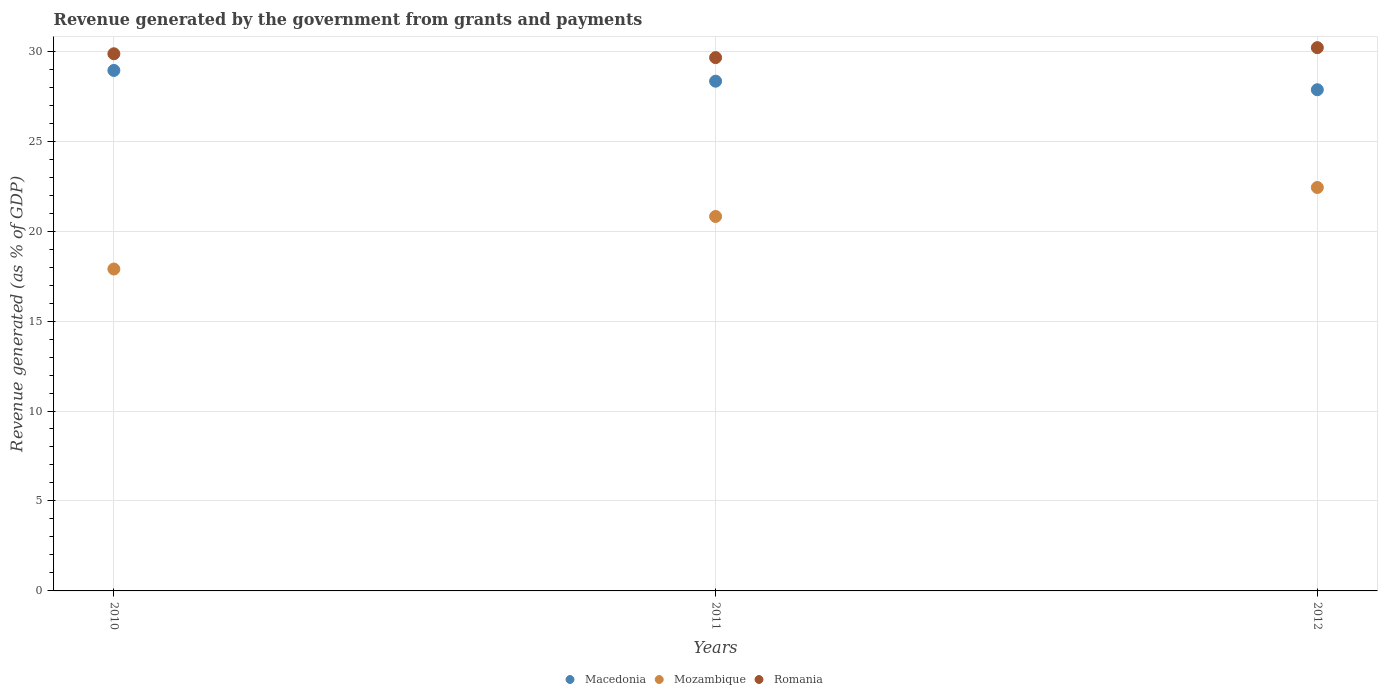What is the revenue generated by the government in Mozambique in 2011?
Provide a short and direct response. 20.81. Across all years, what is the maximum revenue generated by the government in Mozambique?
Offer a very short reply. 22.42. Across all years, what is the minimum revenue generated by the government in Romania?
Offer a terse response. 29.64. In which year was the revenue generated by the government in Romania maximum?
Provide a short and direct response. 2012. What is the total revenue generated by the government in Romania in the graph?
Your response must be concise. 89.69. What is the difference between the revenue generated by the government in Macedonia in 2011 and that in 2012?
Give a very brief answer. 0.48. What is the difference between the revenue generated by the government in Mozambique in 2011 and the revenue generated by the government in Romania in 2012?
Your answer should be compact. -9.38. What is the average revenue generated by the government in Macedonia per year?
Give a very brief answer. 28.37. In the year 2011, what is the difference between the revenue generated by the government in Mozambique and revenue generated by the government in Romania?
Give a very brief answer. -8.83. What is the ratio of the revenue generated by the government in Macedonia in 2010 to that in 2011?
Ensure brevity in your answer.  1.02. Is the revenue generated by the government in Macedonia in 2010 less than that in 2012?
Keep it short and to the point. No. What is the difference between the highest and the second highest revenue generated by the government in Macedonia?
Your answer should be compact. 0.6. What is the difference between the highest and the lowest revenue generated by the government in Mozambique?
Provide a succinct answer. 4.53. In how many years, is the revenue generated by the government in Macedonia greater than the average revenue generated by the government in Macedonia taken over all years?
Ensure brevity in your answer.  1. Does the revenue generated by the government in Mozambique monotonically increase over the years?
Keep it short and to the point. Yes. Is the revenue generated by the government in Mozambique strictly greater than the revenue generated by the government in Romania over the years?
Provide a succinct answer. No. How many dotlines are there?
Ensure brevity in your answer.  3. How many years are there in the graph?
Provide a short and direct response. 3. Does the graph contain any zero values?
Provide a succinct answer. No. Does the graph contain grids?
Offer a very short reply. Yes. How are the legend labels stacked?
Ensure brevity in your answer.  Horizontal. What is the title of the graph?
Provide a short and direct response. Revenue generated by the government from grants and payments. Does "Algeria" appear as one of the legend labels in the graph?
Keep it short and to the point. No. What is the label or title of the Y-axis?
Make the answer very short. Revenue generated (as % of GDP). What is the Revenue generated (as % of GDP) in Macedonia in 2010?
Ensure brevity in your answer.  28.93. What is the Revenue generated (as % of GDP) of Mozambique in 2010?
Your answer should be very brief. 17.89. What is the Revenue generated (as % of GDP) of Romania in 2010?
Provide a short and direct response. 29.86. What is the Revenue generated (as % of GDP) of Macedonia in 2011?
Your response must be concise. 28.33. What is the Revenue generated (as % of GDP) in Mozambique in 2011?
Make the answer very short. 20.81. What is the Revenue generated (as % of GDP) in Romania in 2011?
Ensure brevity in your answer.  29.64. What is the Revenue generated (as % of GDP) in Macedonia in 2012?
Offer a very short reply. 27.86. What is the Revenue generated (as % of GDP) in Mozambique in 2012?
Give a very brief answer. 22.42. What is the Revenue generated (as % of GDP) of Romania in 2012?
Keep it short and to the point. 30.2. Across all years, what is the maximum Revenue generated (as % of GDP) in Macedonia?
Your response must be concise. 28.93. Across all years, what is the maximum Revenue generated (as % of GDP) of Mozambique?
Offer a very short reply. 22.42. Across all years, what is the maximum Revenue generated (as % of GDP) in Romania?
Your answer should be very brief. 30.2. Across all years, what is the minimum Revenue generated (as % of GDP) in Macedonia?
Provide a succinct answer. 27.86. Across all years, what is the minimum Revenue generated (as % of GDP) of Mozambique?
Make the answer very short. 17.89. Across all years, what is the minimum Revenue generated (as % of GDP) in Romania?
Your answer should be very brief. 29.64. What is the total Revenue generated (as % of GDP) of Macedonia in the graph?
Provide a short and direct response. 85.12. What is the total Revenue generated (as % of GDP) of Mozambique in the graph?
Provide a short and direct response. 61.13. What is the total Revenue generated (as % of GDP) in Romania in the graph?
Ensure brevity in your answer.  89.69. What is the difference between the Revenue generated (as % of GDP) of Macedonia in 2010 and that in 2011?
Your answer should be very brief. 0.6. What is the difference between the Revenue generated (as % of GDP) in Mozambique in 2010 and that in 2011?
Provide a succinct answer. -2.92. What is the difference between the Revenue generated (as % of GDP) of Romania in 2010 and that in 2011?
Offer a very short reply. 0.21. What is the difference between the Revenue generated (as % of GDP) in Macedonia in 2010 and that in 2012?
Offer a terse response. 1.07. What is the difference between the Revenue generated (as % of GDP) of Mozambique in 2010 and that in 2012?
Offer a terse response. -4.53. What is the difference between the Revenue generated (as % of GDP) in Romania in 2010 and that in 2012?
Your answer should be very brief. -0.34. What is the difference between the Revenue generated (as % of GDP) in Macedonia in 2011 and that in 2012?
Provide a short and direct response. 0.48. What is the difference between the Revenue generated (as % of GDP) in Mozambique in 2011 and that in 2012?
Your answer should be very brief. -1.61. What is the difference between the Revenue generated (as % of GDP) of Romania in 2011 and that in 2012?
Give a very brief answer. -0.55. What is the difference between the Revenue generated (as % of GDP) of Macedonia in 2010 and the Revenue generated (as % of GDP) of Mozambique in 2011?
Your answer should be very brief. 8.12. What is the difference between the Revenue generated (as % of GDP) of Macedonia in 2010 and the Revenue generated (as % of GDP) of Romania in 2011?
Your answer should be compact. -0.71. What is the difference between the Revenue generated (as % of GDP) in Mozambique in 2010 and the Revenue generated (as % of GDP) in Romania in 2011?
Give a very brief answer. -11.75. What is the difference between the Revenue generated (as % of GDP) in Macedonia in 2010 and the Revenue generated (as % of GDP) in Mozambique in 2012?
Your response must be concise. 6.51. What is the difference between the Revenue generated (as % of GDP) in Macedonia in 2010 and the Revenue generated (as % of GDP) in Romania in 2012?
Provide a succinct answer. -1.27. What is the difference between the Revenue generated (as % of GDP) in Mozambique in 2010 and the Revenue generated (as % of GDP) in Romania in 2012?
Give a very brief answer. -12.3. What is the difference between the Revenue generated (as % of GDP) of Macedonia in 2011 and the Revenue generated (as % of GDP) of Mozambique in 2012?
Your response must be concise. 5.91. What is the difference between the Revenue generated (as % of GDP) of Macedonia in 2011 and the Revenue generated (as % of GDP) of Romania in 2012?
Make the answer very short. -1.86. What is the difference between the Revenue generated (as % of GDP) of Mozambique in 2011 and the Revenue generated (as % of GDP) of Romania in 2012?
Keep it short and to the point. -9.38. What is the average Revenue generated (as % of GDP) of Macedonia per year?
Give a very brief answer. 28.37. What is the average Revenue generated (as % of GDP) in Mozambique per year?
Provide a short and direct response. 20.38. What is the average Revenue generated (as % of GDP) of Romania per year?
Make the answer very short. 29.9. In the year 2010, what is the difference between the Revenue generated (as % of GDP) of Macedonia and Revenue generated (as % of GDP) of Mozambique?
Make the answer very short. 11.04. In the year 2010, what is the difference between the Revenue generated (as % of GDP) in Macedonia and Revenue generated (as % of GDP) in Romania?
Keep it short and to the point. -0.93. In the year 2010, what is the difference between the Revenue generated (as % of GDP) of Mozambique and Revenue generated (as % of GDP) of Romania?
Your response must be concise. -11.96. In the year 2011, what is the difference between the Revenue generated (as % of GDP) of Macedonia and Revenue generated (as % of GDP) of Mozambique?
Provide a short and direct response. 7.52. In the year 2011, what is the difference between the Revenue generated (as % of GDP) in Macedonia and Revenue generated (as % of GDP) in Romania?
Give a very brief answer. -1.31. In the year 2011, what is the difference between the Revenue generated (as % of GDP) in Mozambique and Revenue generated (as % of GDP) in Romania?
Make the answer very short. -8.83. In the year 2012, what is the difference between the Revenue generated (as % of GDP) in Macedonia and Revenue generated (as % of GDP) in Mozambique?
Make the answer very short. 5.43. In the year 2012, what is the difference between the Revenue generated (as % of GDP) in Macedonia and Revenue generated (as % of GDP) in Romania?
Provide a short and direct response. -2.34. In the year 2012, what is the difference between the Revenue generated (as % of GDP) of Mozambique and Revenue generated (as % of GDP) of Romania?
Make the answer very short. -7.77. What is the ratio of the Revenue generated (as % of GDP) of Macedonia in 2010 to that in 2011?
Your response must be concise. 1.02. What is the ratio of the Revenue generated (as % of GDP) in Mozambique in 2010 to that in 2011?
Keep it short and to the point. 0.86. What is the ratio of the Revenue generated (as % of GDP) in Romania in 2010 to that in 2011?
Your answer should be compact. 1.01. What is the ratio of the Revenue generated (as % of GDP) in Mozambique in 2010 to that in 2012?
Ensure brevity in your answer.  0.8. What is the ratio of the Revenue generated (as % of GDP) of Romania in 2010 to that in 2012?
Provide a succinct answer. 0.99. What is the ratio of the Revenue generated (as % of GDP) in Macedonia in 2011 to that in 2012?
Provide a short and direct response. 1.02. What is the ratio of the Revenue generated (as % of GDP) in Mozambique in 2011 to that in 2012?
Make the answer very short. 0.93. What is the ratio of the Revenue generated (as % of GDP) of Romania in 2011 to that in 2012?
Offer a terse response. 0.98. What is the difference between the highest and the second highest Revenue generated (as % of GDP) in Macedonia?
Offer a very short reply. 0.6. What is the difference between the highest and the second highest Revenue generated (as % of GDP) in Mozambique?
Provide a succinct answer. 1.61. What is the difference between the highest and the second highest Revenue generated (as % of GDP) of Romania?
Provide a short and direct response. 0.34. What is the difference between the highest and the lowest Revenue generated (as % of GDP) in Macedonia?
Your answer should be very brief. 1.07. What is the difference between the highest and the lowest Revenue generated (as % of GDP) in Mozambique?
Your answer should be compact. 4.53. What is the difference between the highest and the lowest Revenue generated (as % of GDP) of Romania?
Your answer should be compact. 0.55. 